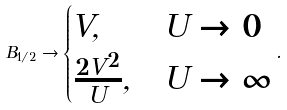Convert formula to latex. <formula><loc_0><loc_0><loc_500><loc_500>B _ { 1 / 2 } \rightarrow \begin{cases} V , & U \rightarrow 0 \\ \frac { 2 V ^ { 2 } } { U } , & U \rightarrow \infty \end{cases} .</formula> 